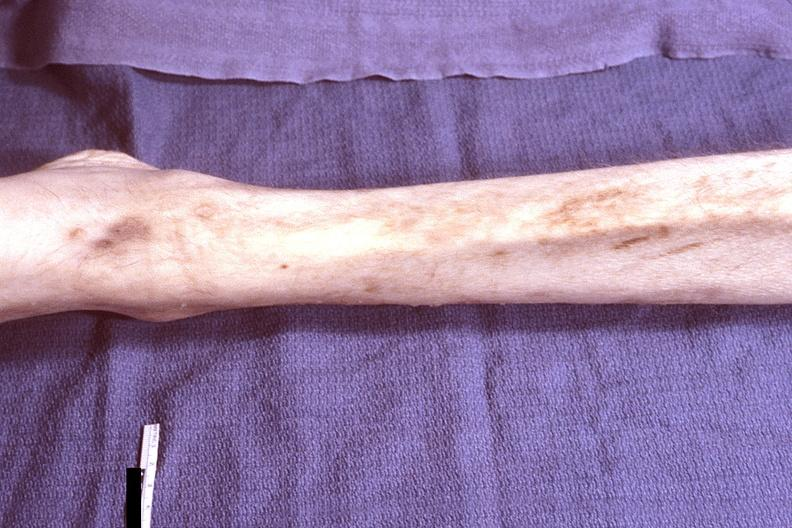s musculoskeletal present?
Answer the question using a single word or phrase. Yes 